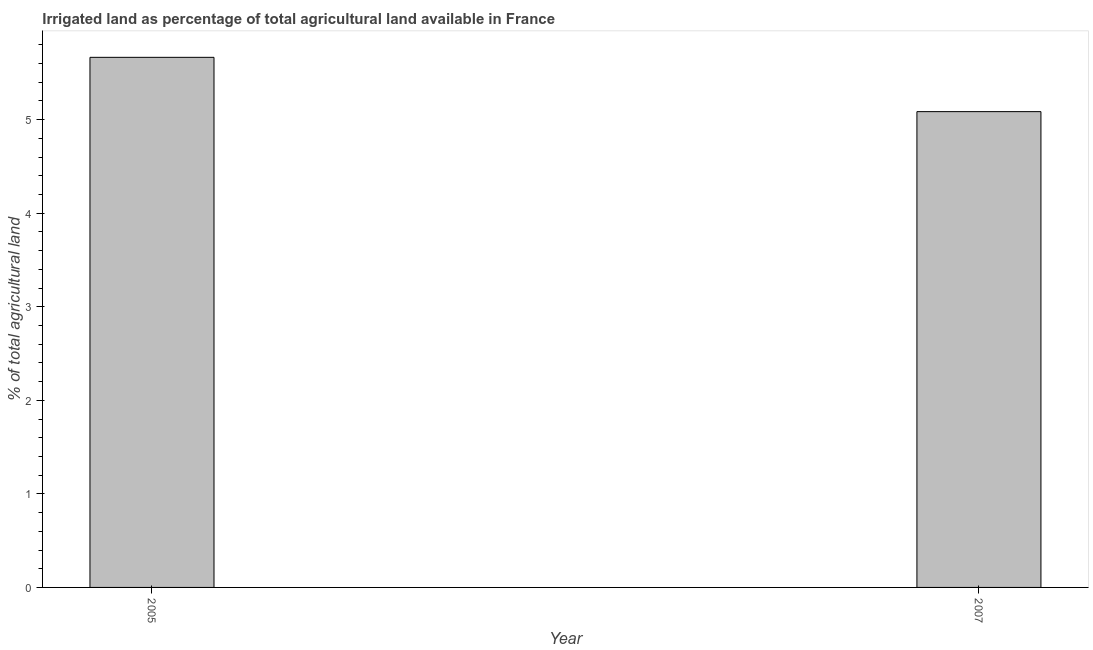What is the title of the graph?
Offer a terse response. Irrigated land as percentage of total agricultural land available in France. What is the label or title of the Y-axis?
Make the answer very short. % of total agricultural land. What is the percentage of agricultural irrigated land in 2005?
Give a very brief answer. 5.67. Across all years, what is the maximum percentage of agricultural irrigated land?
Your answer should be compact. 5.67. Across all years, what is the minimum percentage of agricultural irrigated land?
Your answer should be very brief. 5.09. In which year was the percentage of agricultural irrigated land minimum?
Keep it short and to the point. 2007. What is the sum of the percentage of agricultural irrigated land?
Offer a very short reply. 10.75. What is the difference between the percentage of agricultural irrigated land in 2005 and 2007?
Offer a very short reply. 0.58. What is the average percentage of agricultural irrigated land per year?
Your response must be concise. 5.38. What is the median percentage of agricultural irrigated land?
Your answer should be very brief. 5.38. Do a majority of the years between 2007 and 2005 (inclusive) have percentage of agricultural irrigated land greater than 2.2 %?
Your answer should be compact. No. What is the ratio of the percentage of agricultural irrigated land in 2005 to that in 2007?
Keep it short and to the point. 1.11. In how many years, is the percentage of agricultural irrigated land greater than the average percentage of agricultural irrigated land taken over all years?
Offer a very short reply. 1. Are all the bars in the graph horizontal?
Give a very brief answer. No. What is the difference between two consecutive major ticks on the Y-axis?
Your answer should be very brief. 1. What is the % of total agricultural land of 2005?
Your answer should be very brief. 5.67. What is the % of total agricultural land in 2007?
Provide a short and direct response. 5.09. What is the difference between the % of total agricultural land in 2005 and 2007?
Your answer should be compact. 0.58. What is the ratio of the % of total agricultural land in 2005 to that in 2007?
Offer a terse response. 1.11. 